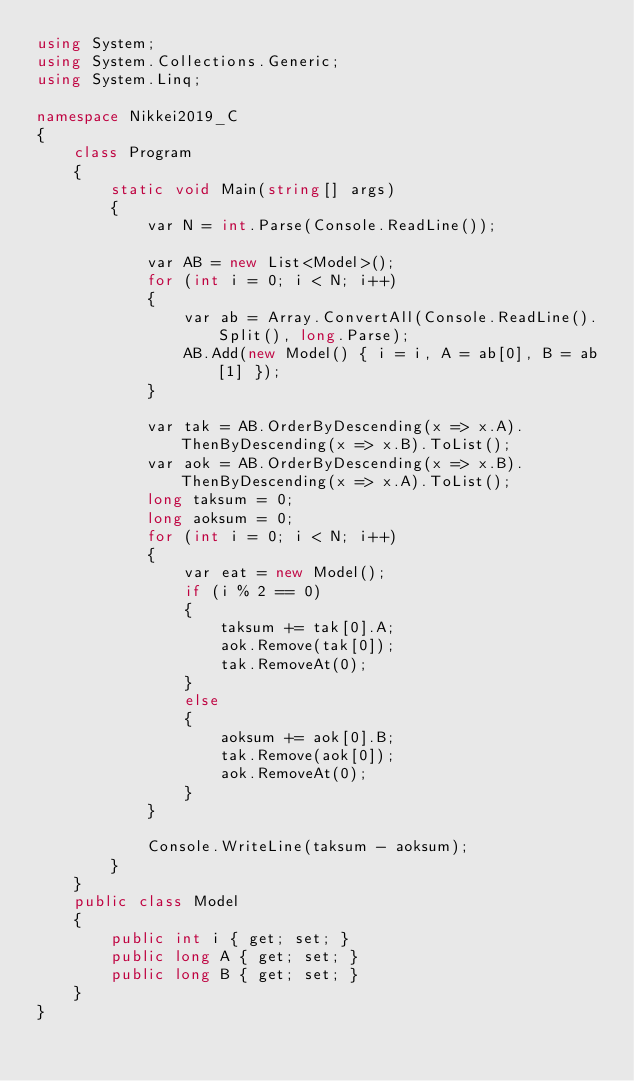Convert code to text. <code><loc_0><loc_0><loc_500><loc_500><_C#_>using System;
using System.Collections.Generic;
using System.Linq;

namespace Nikkei2019_C
{
    class Program
    {
        static void Main(string[] args)
        {
            var N = int.Parse(Console.ReadLine());

            var AB = new List<Model>();
            for (int i = 0; i < N; i++)
            {
                var ab = Array.ConvertAll(Console.ReadLine().Split(), long.Parse);
                AB.Add(new Model() { i = i, A = ab[0], B = ab[1] });
            }

            var tak = AB.OrderByDescending(x => x.A).ThenByDescending(x => x.B).ToList();
            var aok = AB.OrderByDescending(x => x.B).ThenByDescending(x => x.A).ToList();
            long taksum = 0;
            long aoksum = 0;
            for (int i = 0; i < N; i++)
            {
                var eat = new Model();
                if (i % 2 == 0)
                {
                    taksum += tak[0].A;
                    aok.Remove(tak[0]);
                    tak.RemoveAt(0);
                }
                else
                {
                    aoksum += aok[0].B;
                    tak.Remove(aok[0]);
                    aok.RemoveAt(0);
                }
            }

            Console.WriteLine(taksum - aoksum);
        }
    }
    public class Model
    {
        public int i { get; set; }
        public long A { get; set; }
        public long B { get; set; }
    }
}
</code> 